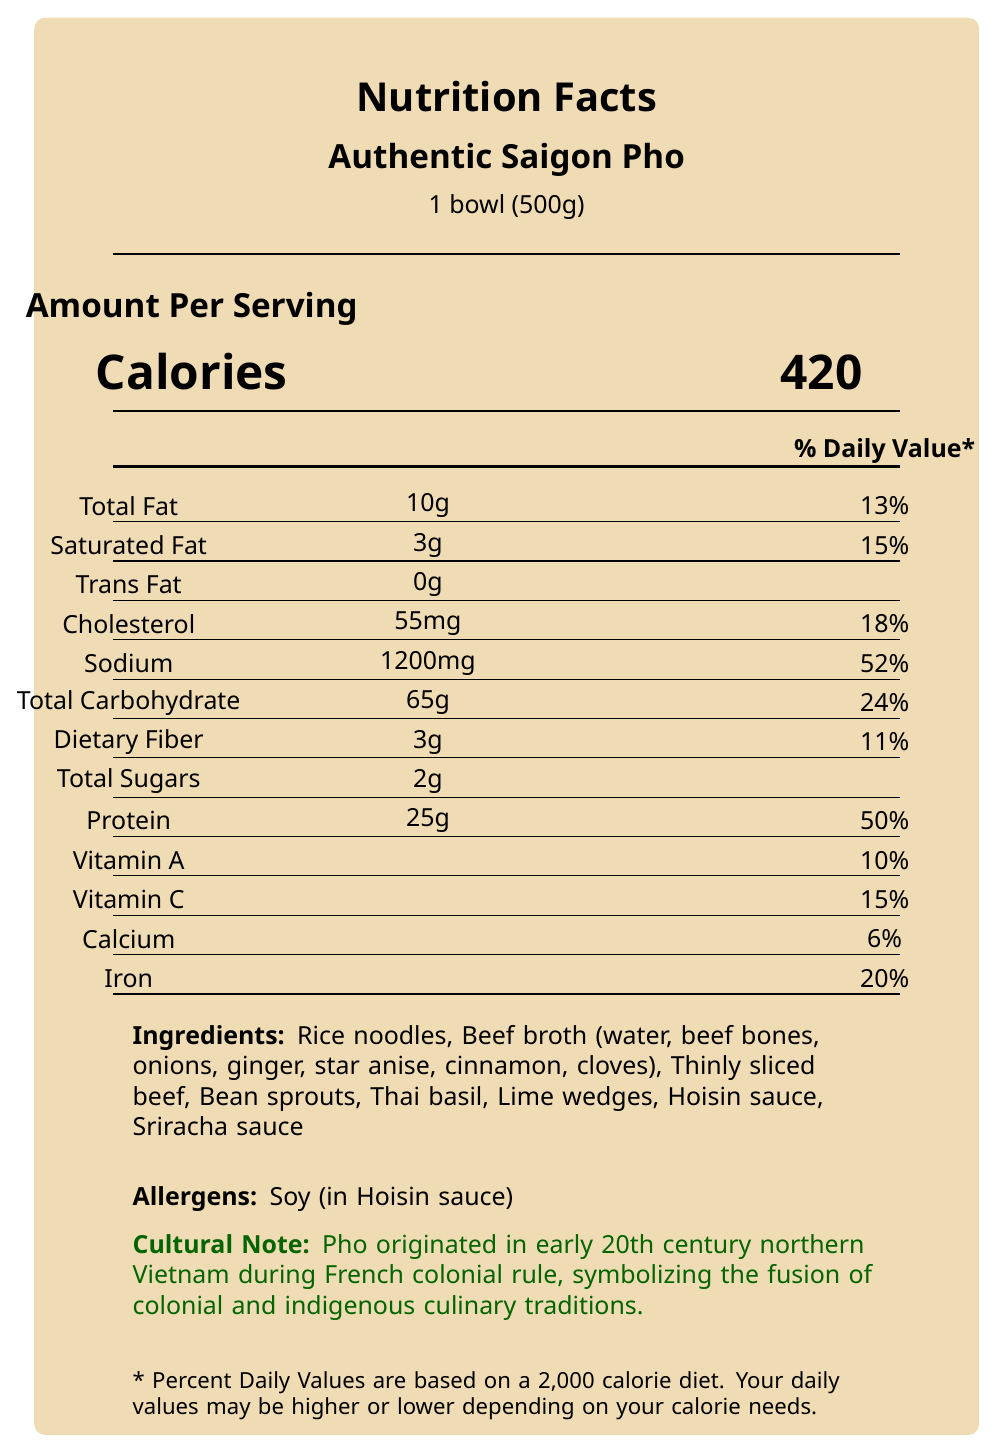what is the product name? The product name is clearly listed at the top of the document.
Answer: Authentic Saigon Pho What is the serving size for Authentic Saigon Pho? The serving size is listed under the product name near the top of the document.
Answer: 1 bowl (500g) How many calories are in one serving of Authentic Saigon Pho? The calorie count is displayed prominently in large font beneath the "Amount Per Serving" heading.
Answer: 420 What is the sodium content in one serving of Authentic Saigon Pho? The sodium content is listed in the nutritional information section under "Sodium."
Answer: 1200mg What are the primary ingredients in Authentic Saigon Pho? The ingredients are listed in the "Ingredients" section near the bottom of the document.
Answer: Rice noodles, Beef broth, Thinly sliced beef, Bean sprouts, Thai basil, Lime wedges, Hoisin sauce, Sriracha sauce How much iron is in one serving of Authentic Saigon Pho? The percentage of the daily value of iron is listed at the bottom of the nutritional information section.
Answer: 20% What allergens are present in Authentic Saigon Pho? The allergens section specifies that soy (in Hoisin sauce) is present.
Answer: Soy What is one main cultural note about pho mentioned in the document? This cultural note is highlighted near the bottom of the document in a green font for emphasis.
Answer: Pho originated in early 20th century northern Vietnam during French colonial rule, symbolizing the fusion of colonial and indigenous culinary traditions. What region is Authentic Saigon Pho originally from? A. Ho Chi Minh City, Vietnam B. Hanoi, Vietnam C. Saigon, Vietnam The document states that the region of origin is Hanoi, Vietnam, which is found in the preparation method section.
Answer: B. Hanoi, Vietnam Which nutrient has the highest percentage of the daily value in a serving of Authentic Saigon Pho? A. Total Fat B. Sodium C. Iron The sodium content has the highest percentage of the daily value at 52%, which is listed in the nutritional information section.
Answer: B. Sodium Does Authentic Saigon Pho contain any trans fat? The document lists the trans fat content as 0g in the nutritional information section.
Answer: No Summarize the main idea of the document. The summary encompasses key details about the dish's nutritional content, cultural significance, and sustainability practices.
Answer: The document provides nutritional information, cultural background, and ingredient details for Authentic Saigon Pho. This dish reflects a fusion of French and Vietnamese culinary traditions, originating in early 20th century Hanoi during French colonial rule. The pho is noted for its high protein content, significant iron levels, and use of local, sustainable ingredients, supporting small-scale farmers in Vietnam. What is the sustainability information mentioned? This information is found in the "sustainability info" section.
Answer: Ingredients sourced from local Vietnamese markets to support small-scale farmers describe the preparation method of Authentic Saigon Pho The preparation method is outlined clearly in the document.
Answer: Slow-simmered broth, rice noodles cooked separately, served with fresh herbs and sauces Which vitamin is more abundant in Authentic Saigon Pho (Vitamin A or Vitamin C)? The percentage daily values are 10% for Vitamin A and 15% for Vitamin C, as listed in the nutritional information section.
Answer: Vitamin C What adaptation does pho represent according to a postcolonial perspective in the document? This perspective is described in the "postcolonial perspective" section.
Answer: Pho represents Vietnam's ability to adapt foreign influences while maintaining its cultural identity How many servings are in one container of Authentic Saigon Pho? The number of servings per container is specified at the top of the document.
Answer: 1 What prevents non-locals from making Authentic Saigon Pho exactly as in Vietnam? The document does mention ingredients sourced from local markets to support small-scale farmers, but it does not provide details on what might prevent non-locals from replicating the dish exactly.
Answer: Not enough information Does the document mention anything about the use of anti-inflammatory compounds? It specifies that the dish contains anti-inflammatory compounds from ginger and cinnamon, as mentioned in the nutritional highlights.
Answer: Yes 